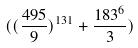<formula> <loc_0><loc_0><loc_500><loc_500>( ( \frac { 4 9 5 } { 9 } ) ^ { 1 3 1 } + \frac { 1 8 3 ^ { 6 } } { 3 } )</formula> 